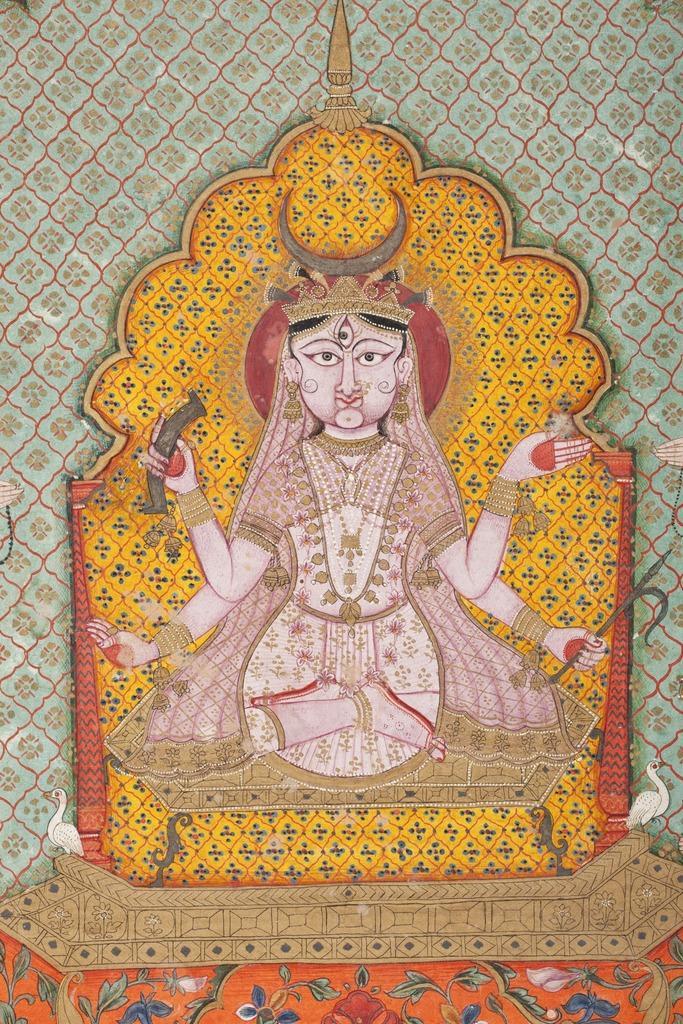Describe this image in one or two sentences. In this picture we can see the picture of a goddess, might be on a wall or on a stone. 